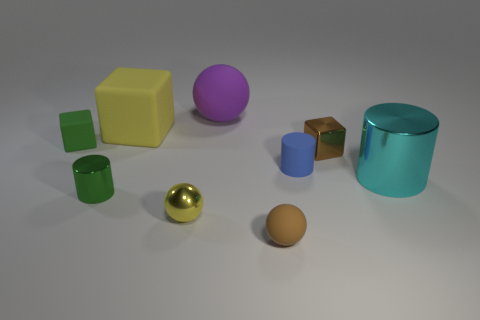How many small metal things are right of the brown rubber sphere and on the left side of the tiny brown metal object?
Your answer should be compact. 0. The metal sphere is what color?
Offer a very short reply. Yellow. Is there a large brown sphere that has the same material as the small brown block?
Give a very brief answer. No. There is a tiny cylinder that is to the right of the big object that is left of the large purple sphere; are there any tiny matte objects on the left side of it?
Your response must be concise. Yes. There is a small brown matte thing; are there any green matte things on the left side of it?
Offer a very short reply. Yes. Are there any matte objects that have the same color as the shiny sphere?
Keep it short and to the point. Yes. How many tiny objects are either cyan metal spheres or brown metal objects?
Ensure brevity in your answer.  1. Does the green thing that is in front of the green rubber cube have the same material as the small green cube?
Keep it short and to the point. No. There is a brown thing that is left of the cube in front of the matte thing left of the large yellow object; what shape is it?
Give a very brief answer. Sphere. How many brown things are either big rubber blocks or small things?
Your answer should be compact. 2. 